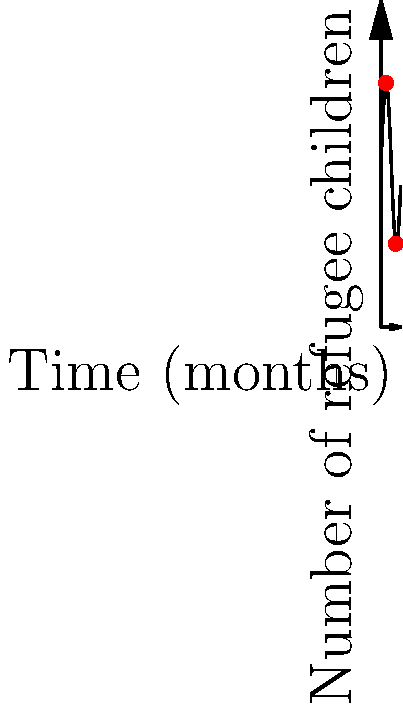The graph represents the number of refugee children arriving over a 12-month period. If $f(t)$ represents the number of children at time $t$ in months, calculate the average rate of change in arrivals between months 3 and 9. To find the average rate of change between two points, we use the formula:

$$ \text{Average rate of change} = \frac{f(b) - f(a)}{b - a} $$

Where $a = 3$ and $b = 9$ (months).

1) First, we need to find $f(3)$ and $f(9)$:
   $f(t) = 100 + 50\sin(t/2)$
   
   $f(3) = 100 + 50\sin(3/2) \approx 135.05$
   $f(9) = 100 + 50\sin(9/2) \approx 64.95$

2) Now we can plug these values into our formula:

   $$ \text{Average rate of change} = \frac{f(9) - f(3)}{9 - 3} = \frac{64.95 - 135.05}{6} \approx -11.68 $$

3) Interpret the result: The average rate of change is approximately -11.68 children per month.
Answer: -11.68 children/month 